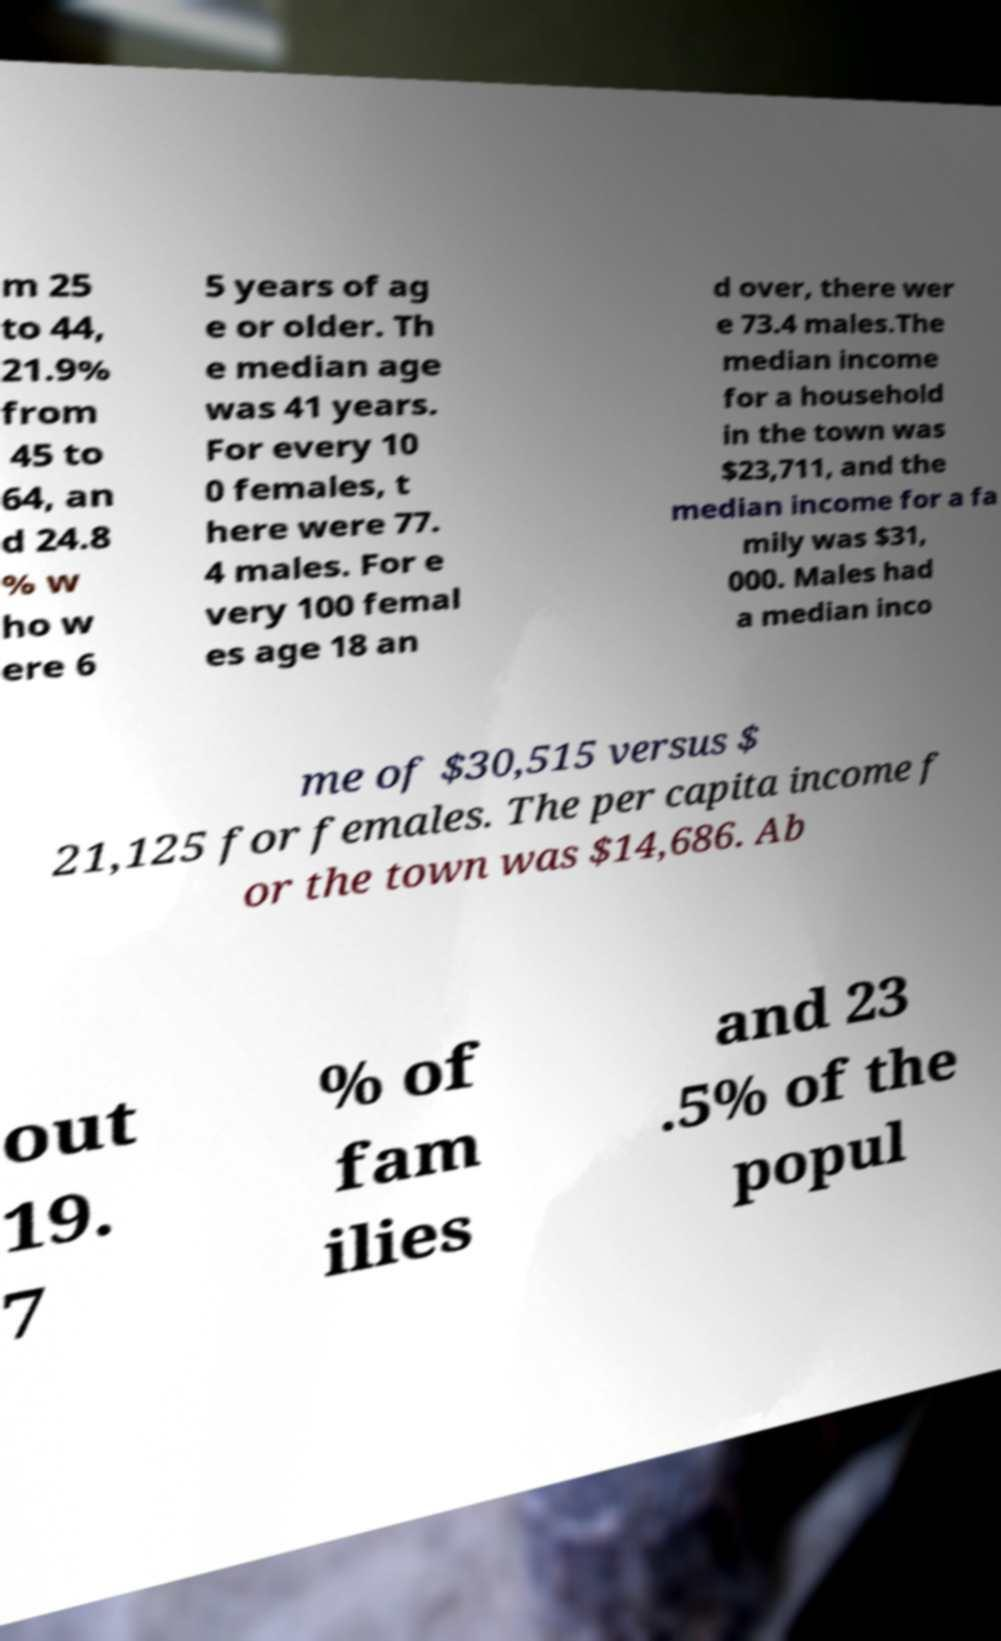Could you extract and type out the text from this image? m 25 to 44, 21.9% from 45 to 64, an d 24.8 % w ho w ere 6 5 years of ag e or older. Th e median age was 41 years. For every 10 0 females, t here were 77. 4 males. For e very 100 femal es age 18 an d over, there wer e 73.4 males.The median income for a household in the town was $23,711, and the median income for a fa mily was $31, 000. Males had a median inco me of $30,515 versus $ 21,125 for females. The per capita income f or the town was $14,686. Ab out 19. 7 % of fam ilies and 23 .5% of the popul 